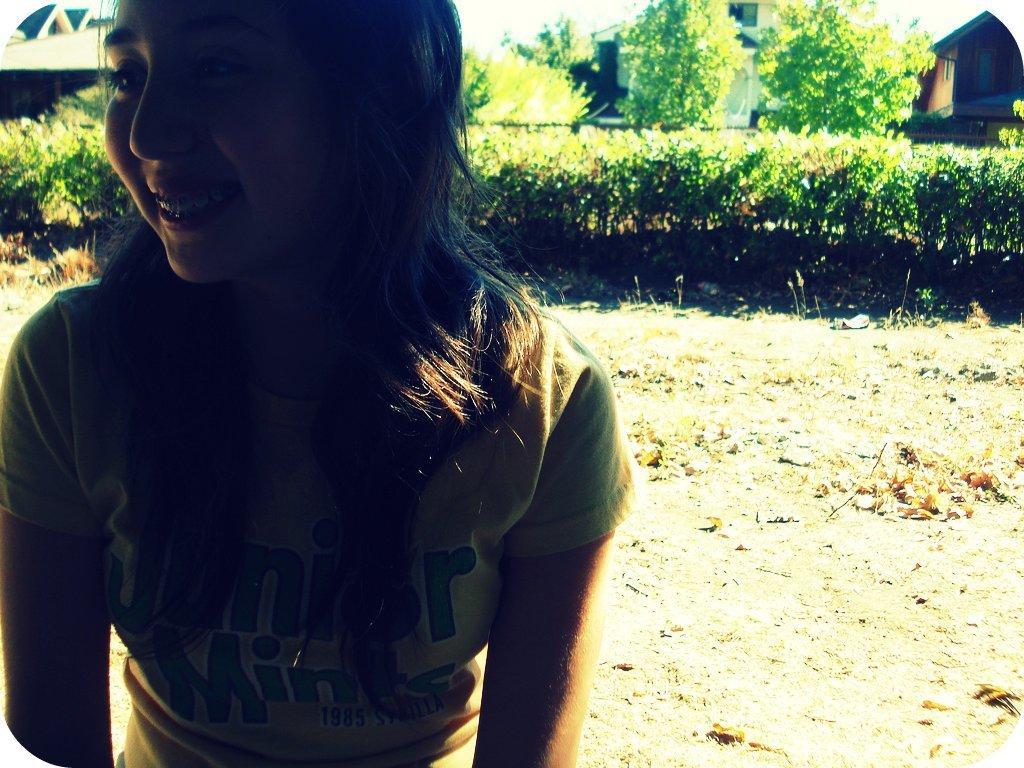Please provide a concise description of this image. This picture might be taken outside of the city and it is very sunny. In this image, on the left side, we can see a woman sitting. In the background, we can see some trees, plants, houses, buildings. On top there is a sky, at the bottom there is a land with some stones and leaves. 